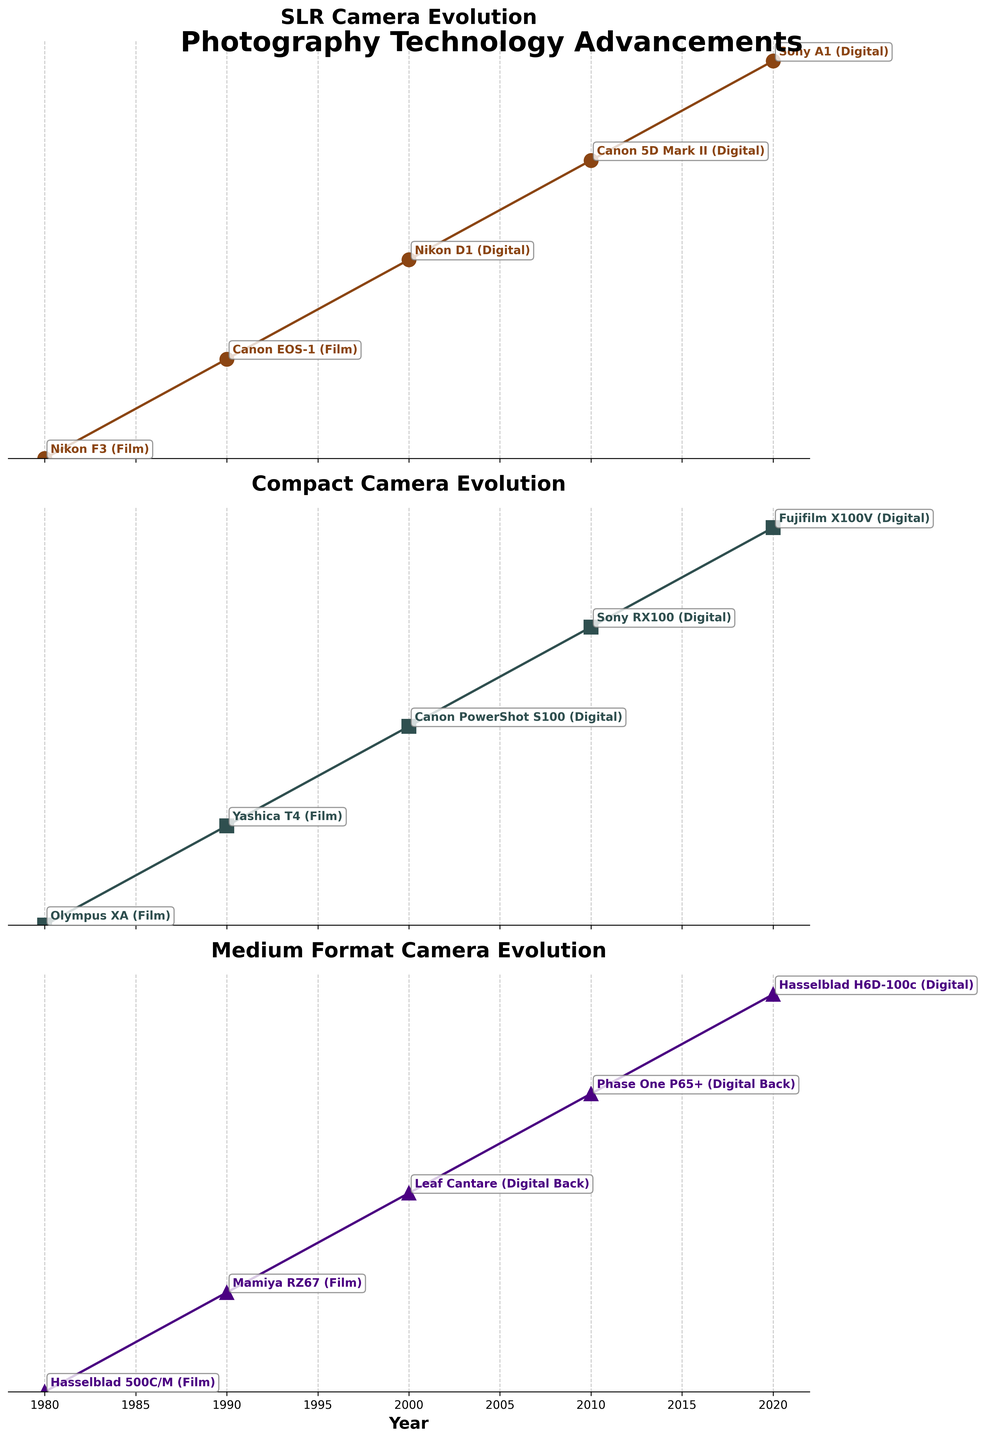What is the title of the figure? The title is displayed at the top of the figure in a prominent font.
Answer: Photography Technology Advancements How many subplots are there vertically? The figure consists of equally spaced horizontal sections, each representing a subplot. Counting these sections shows there are three subplots.
Answer: 3 What type of camera advancements are shown in the top subplot? The title of the top subplot indicates the type of cameras being showcased, which is displayed prominently above the graph.
Answer: SLR Which camera model represented the Compact Camera advancements in 2000? Observing the data point corresponding to the year 2000 in the second subplot, and checking the annotation next to it reveals the camera model.
Answer: Canon PowerShot S100 When did Medium Format cameras transition from film to digital, according to the figure? By examining the annotations in the third subplot, it is clear that cameras were listed as film until 2000, where a digital model starts being listed.
Answer: 2000 Which camera type had its latest model in 2020 labeled as "Fujifilm X100V"? By checking the annotations for the year 2020 in each subplot, it is found that the second subplot, representing Compact Cameras, lists the "Fujifilm X100V".
Answer: Compact How many different camera models are shown in total across the whole figure? Each subplot has one camera model for each of the five years. Since there are three subplots, totaling three camera types across five years, there are 3 x 5 = 15 models.
Answer: 15 Compare the SLR and Compact Camera models in the year 1990. Which models are listed? By examining the first and second subplots for the year 1990, the annotations next to the data points show Canon EOS-1 for SLR and Yashica T4 for Compact.
Answer: Canon EOS-1 and Yashica T4 Which camera advancements are shown to be digital in 2010? Reviewing the annotations for the year 2010 in all three subplots, all listed models are labeled as digital ("Canon 5D Mark II", "Sony RX100", "Phase One P65+").
Answer: Canon 5D Mark II, Sony RX100, Phase One P65+ Between 1980 and 2020, which camera type has the fewest labeled data points in the figure? Each subplot consistently has a model labeled for each year. Therefore, all camera types (SLR, Compact, Medium Format) have an equal number of labeled data points, which is five each.
Answer: None (all have 5) 